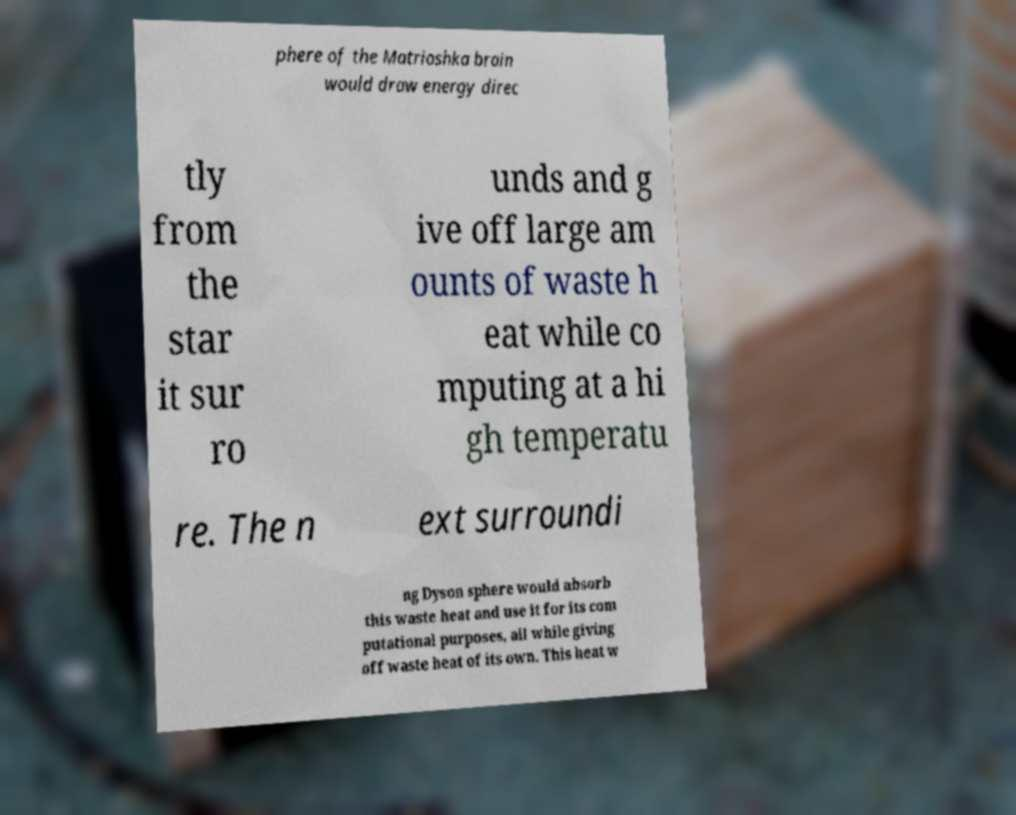There's text embedded in this image that I need extracted. Can you transcribe it verbatim? phere of the Matrioshka brain would draw energy direc tly from the star it sur ro unds and g ive off large am ounts of waste h eat while co mputing at a hi gh temperatu re. The n ext surroundi ng Dyson sphere would absorb this waste heat and use it for its com putational purposes, all while giving off waste heat of its own. This heat w 